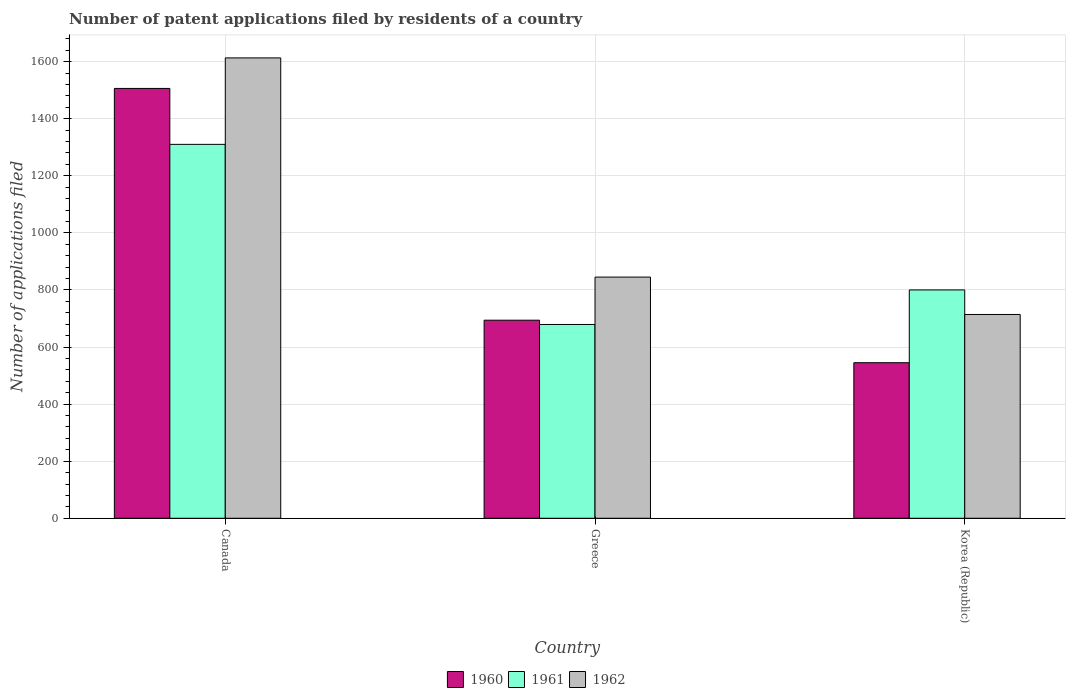Are the number of bars per tick equal to the number of legend labels?
Keep it short and to the point. Yes. Are the number of bars on each tick of the X-axis equal?
Make the answer very short. Yes. How many bars are there on the 2nd tick from the left?
Offer a terse response. 3. How many bars are there on the 2nd tick from the right?
Make the answer very short. 3. In how many cases, is the number of bars for a given country not equal to the number of legend labels?
Provide a short and direct response. 0. What is the number of applications filed in 1960 in Canada?
Ensure brevity in your answer.  1506. Across all countries, what is the maximum number of applications filed in 1962?
Your answer should be very brief. 1613. Across all countries, what is the minimum number of applications filed in 1961?
Your response must be concise. 679. What is the total number of applications filed in 1960 in the graph?
Ensure brevity in your answer.  2745. What is the difference between the number of applications filed in 1961 in Greece and that in Korea (Republic)?
Offer a terse response. -121. What is the difference between the number of applications filed in 1962 in Canada and the number of applications filed in 1960 in Greece?
Your answer should be very brief. 919. What is the average number of applications filed in 1962 per country?
Offer a very short reply. 1057.33. What is the difference between the number of applications filed of/in 1962 and number of applications filed of/in 1960 in Canada?
Provide a short and direct response. 107. What is the ratio of the number of applications filed in 1960 in Canada to that in Korea (Republic)?
Give a very brief answer. 2.76. Is the number of applications filed in 1960 in Greece less than that in Korea (Republic)?
Your answer should be compact. No. Is the difference between the number of applications filed in 1962 in Greece and Korea (Republic) greater than the difference between the number of applications filed in 1960 in Greece and Korea (Republic)?
Offer a very short reply. No. What is the difference between the highest and the second highest number of applications filed in 1962?
Your response must be concise. -131. What is the difference between the highest and the lowest number of applications filed in 1961?
Give a very brief answer. 631. What does the 2nd bar from the left in Korea (Republic) represents?
Provide a succinct answer. 1961. How many bars are there?
Make the answer very short. 9. How many countries are there in the graph?
Make the answer very short. 3. What is the difference between two consecutive major ticks on the Y-axis?
Provide a short and direct response. 200. Does the graph contain grids?
Keep it short and to the point. Yes. How are the legend labels stacked?
Make the answer very short. Horizontal. What is the title of the graph?
Give a very brief answer. Number of patent applications filed by residents of a country. What is the label or title of the Y-axis?
Give a very brief answer. Number of applications filed. What is the Number of applications filed in 1960 in Canada?
Your answer should be very brief. 1506. What is the Number of applications filed of 1961 in Canada?
Your response must be concise. 1310. What is the Number of applications filed of 1962 in Canada?
Make the answer very short. 1613. What is the Number of applications filed in 1960 in Greece?
Offer a terse response. 694. What is the Number of applications filed of 1961 in Greece?
Ensure brevity in your answer.  679. What is the Number of applications filed of 1962 in Greece?
Your answer should be very brief. 845. What is the Number of applications filed of 1960 in Korea (Republic)?
Keep it short and to the point. 545. What is the Number of applications filed in 1961 in Korea (Republic)?
Provide a short and direct response. 800. What is the Number of applications filed of 1962 in Korea (Republic)?
Offer a terse response. 714. Across all countries, what is the maximum Number of applications filed of 1960?
Your response must be concise. 1506. Across all countries, what is the maximum Number of applications filed of 1961?
Offer a terse response. 1310. Across all countries, what is the maximum Number of applications filed of 1962?
Give a very brief answer. 1613. Across all countries, what is the minimum Number of applications filed in 1960?
Make the answer very short. 545. Across all countries, what is the minimum Number of applications filed of 1961?
Your response must be concise. 679. Across all countries, what is the minimum Number of applications filed of 1962?
Keep it short and to the point. 714. What is the total Number of applications filed of 1960 in the graph?
Ensure brevity in your answer.  2745. What is the total Number of applications filed in 1961 in the graph?
Your answer should be very brief. 2789. What is the total Number of applications filed in 1962 in the graph?
Ensure brevity in your answer.  3172. What is the difference between the Number of applications filed of 1960 in Canada and that in Greece?
Offer a terse response. 812. What is the difference between the Number of applications filed in 1961 in Canada and that in Greece?
Provide a succinct answer. 631. What is the difference between the Number of applications filed of 1962 in Canada and that in Greece?
Your answer should be compact. 768. What is the difference between the Number of applications filed of 1960 in Canada and that in Korea (Republic)?
Make the answer very short. 961. What is the difference between the Number of applications filed of 1961 in Canada and that in Korea (Republic)?
Provide a succinct answer. 510. What is the difference between the Number of applications filed of 1962 in Canada and that in Korea (Republic)?
Ensure brevity in your answer.  899. What is the difference between the Number of applications filed in 1960 in Greece and that in Korea (Republic)?
Ensure brevity in your answer.  149. What is the difference between the Number of applications filed of 1961 in Greece and that in Korea (Republic)?
Your response must be concise. -121. What is the difference between the Number of applications filed in 1962 in Greece and that in Korea (Republic)?
Ensure brevity in your answer.  131. What is the difference between the Number of applications filed in 1960 in Canada and the Number of applications filed in 1961 in Greece?
Keep it short and to the point. 827. What is the difference between the Number of applications filed of 1960 in Canada and the Number of applications filed of 1962 in Greece?
Provide a succinct answer. 661. What is the difference between the Number of applications filed in 1961 in Canada and the Number of applications filed in 1962 in Greece?
Provide a short and direct response. 465. What is the difference between the Number of applications filed in 1960 in Canada and the Number of applications filed in 1961 in Korea (Republic)?
Your answer should be very brief. 706. What is the difference between the Number of applications filed of 1960 in Canada and the Number of applications filed of 1962 in Korea (Republic)?
Provide a succinct answer. 792. What is the difference between the Number of applications filed of 1961 in Canada and the Number of applications filed of 1962 in Korea (Republic)?
Provide a succinct answer. 596. What is the difference between the Number of applications filed of 1960 in Greece and the Number of applications filed of 1961 in Korea (Republic)?
Ensure brevity in your answer.  -106. What is the difference between the Number of applications filed in 1960 in Greece and the Number of applications filed in 1962 in Korea (Republic)?
Offer a very short reply. -20. What is the difference between the Number of applications filed of 1961 in Greece and the Number of applications filed of 1962 in Korea (Republic)?
Your answer should be compact. -35. What is the average Number of applications filed in 1960 per country?
Ensure brevity in your answer.  915. What is the average Number of applications filed of 1961 per country?
Give a very brief answer. 929.67. What is the average Number of applications filed in 1962 per country?
Offer a terse response. 1057.33. What is the difference between the Number of applications filed in 1960 and Number of applications filed in 1961 in Canada?
Your answer should be very brief. 196. What is the difference between the Number of applications filed in 1960 and Number of applications filed in 1962 in Canada?
Ensure brevity in your answer.  -107. What is the difference between the Number of applications filed in 1961 and Number of applications filed in 1962 in Canada?
Your response must be concise. -303. What is the difference between the Number of applications filed of 1960 and Number of applications filed of 1961 in Greece?
Keep it short and to the point. 15. What is the difference between the Number of applications filed in 1960 and Number of applications filed in 1962 in Greece?
Make the answer very short. -151. What is the difference between the Number of applications filed in 1961 and Number of applications filed in 1962 in Greece?
Your answer should be compact. -166. What is the difference between the Number of applications filed of 1960 and Number of applications filed of 1961 in Korea (Republic)?
Make the answer very short. -255. What is the difference between the Number of applications filed of 1960 and Number of applications filed of 1962 in Korea (Republic)?
Your response must be concise. -169. What is the difference between the Number of applications filed of 1961 and Number of applications filed of 1962 in Korea (Republic)?
Make the answer very short. 86. What is the ratio of the Number of applications filed in 1960 in Canada to that in Greece?
Your response must be concise. 2.17. What is the ratio of the Number of applications filed in 1961 in Canada to that in Greece?
Give a very brief answer. 1.93. What is the ratio of the Number of applications filed of 1962 in Canada to that in Greece?
Offer a very short reply. 1.91. What is the ratio of the Number of applications filed in 1960 in Canada to that in Korea (Republic)?
Offer a very short reply. 2.76. What is the ratio of the Number of applications filed in 1961 in Canada to that in Korea (Republic)?
Provide a succinct answer. 1.64. What is the ratio of the Number of applications filed of 1962 in Canada to that in Korea (Republic)?
Provide a short and direct response. 2.26. What is the ratio of the Number of applications filed in 1960 in Greece to that in Korea (Republic)?
Provide a short and direct response. 1.27. What is the ratio of the Number of applications filed in 1961 in Greece to that in Korea (Republic)?
Your response must be concise. 0.85. What is the ratio of the Number of applications filed in 1962 in Greece to that in Korea (Republic)?
Offer a very short reply. 1.18. What is the difference between the highest and the second highest Number of applications filed of 1960?
Offer a terse response. 812. What is the difference between the highest and the second highest Number of applications filed of 1961?
Keep it short and to the point. 510. What is the difference between the highest and the second highest Number of applications filed of 1962?
Offer a terse response. 768. What is the difference between the highest and the lowest Number of applications filed of 1960?
Your response must be concise. 961. What is the difference between the highest and the lowest Number of applications filed in 1961?
Keep it short and to the point. 631. What is the difference between the highest and the lowest Number of applications filed in 1962?
Make the answer very short. 899. 